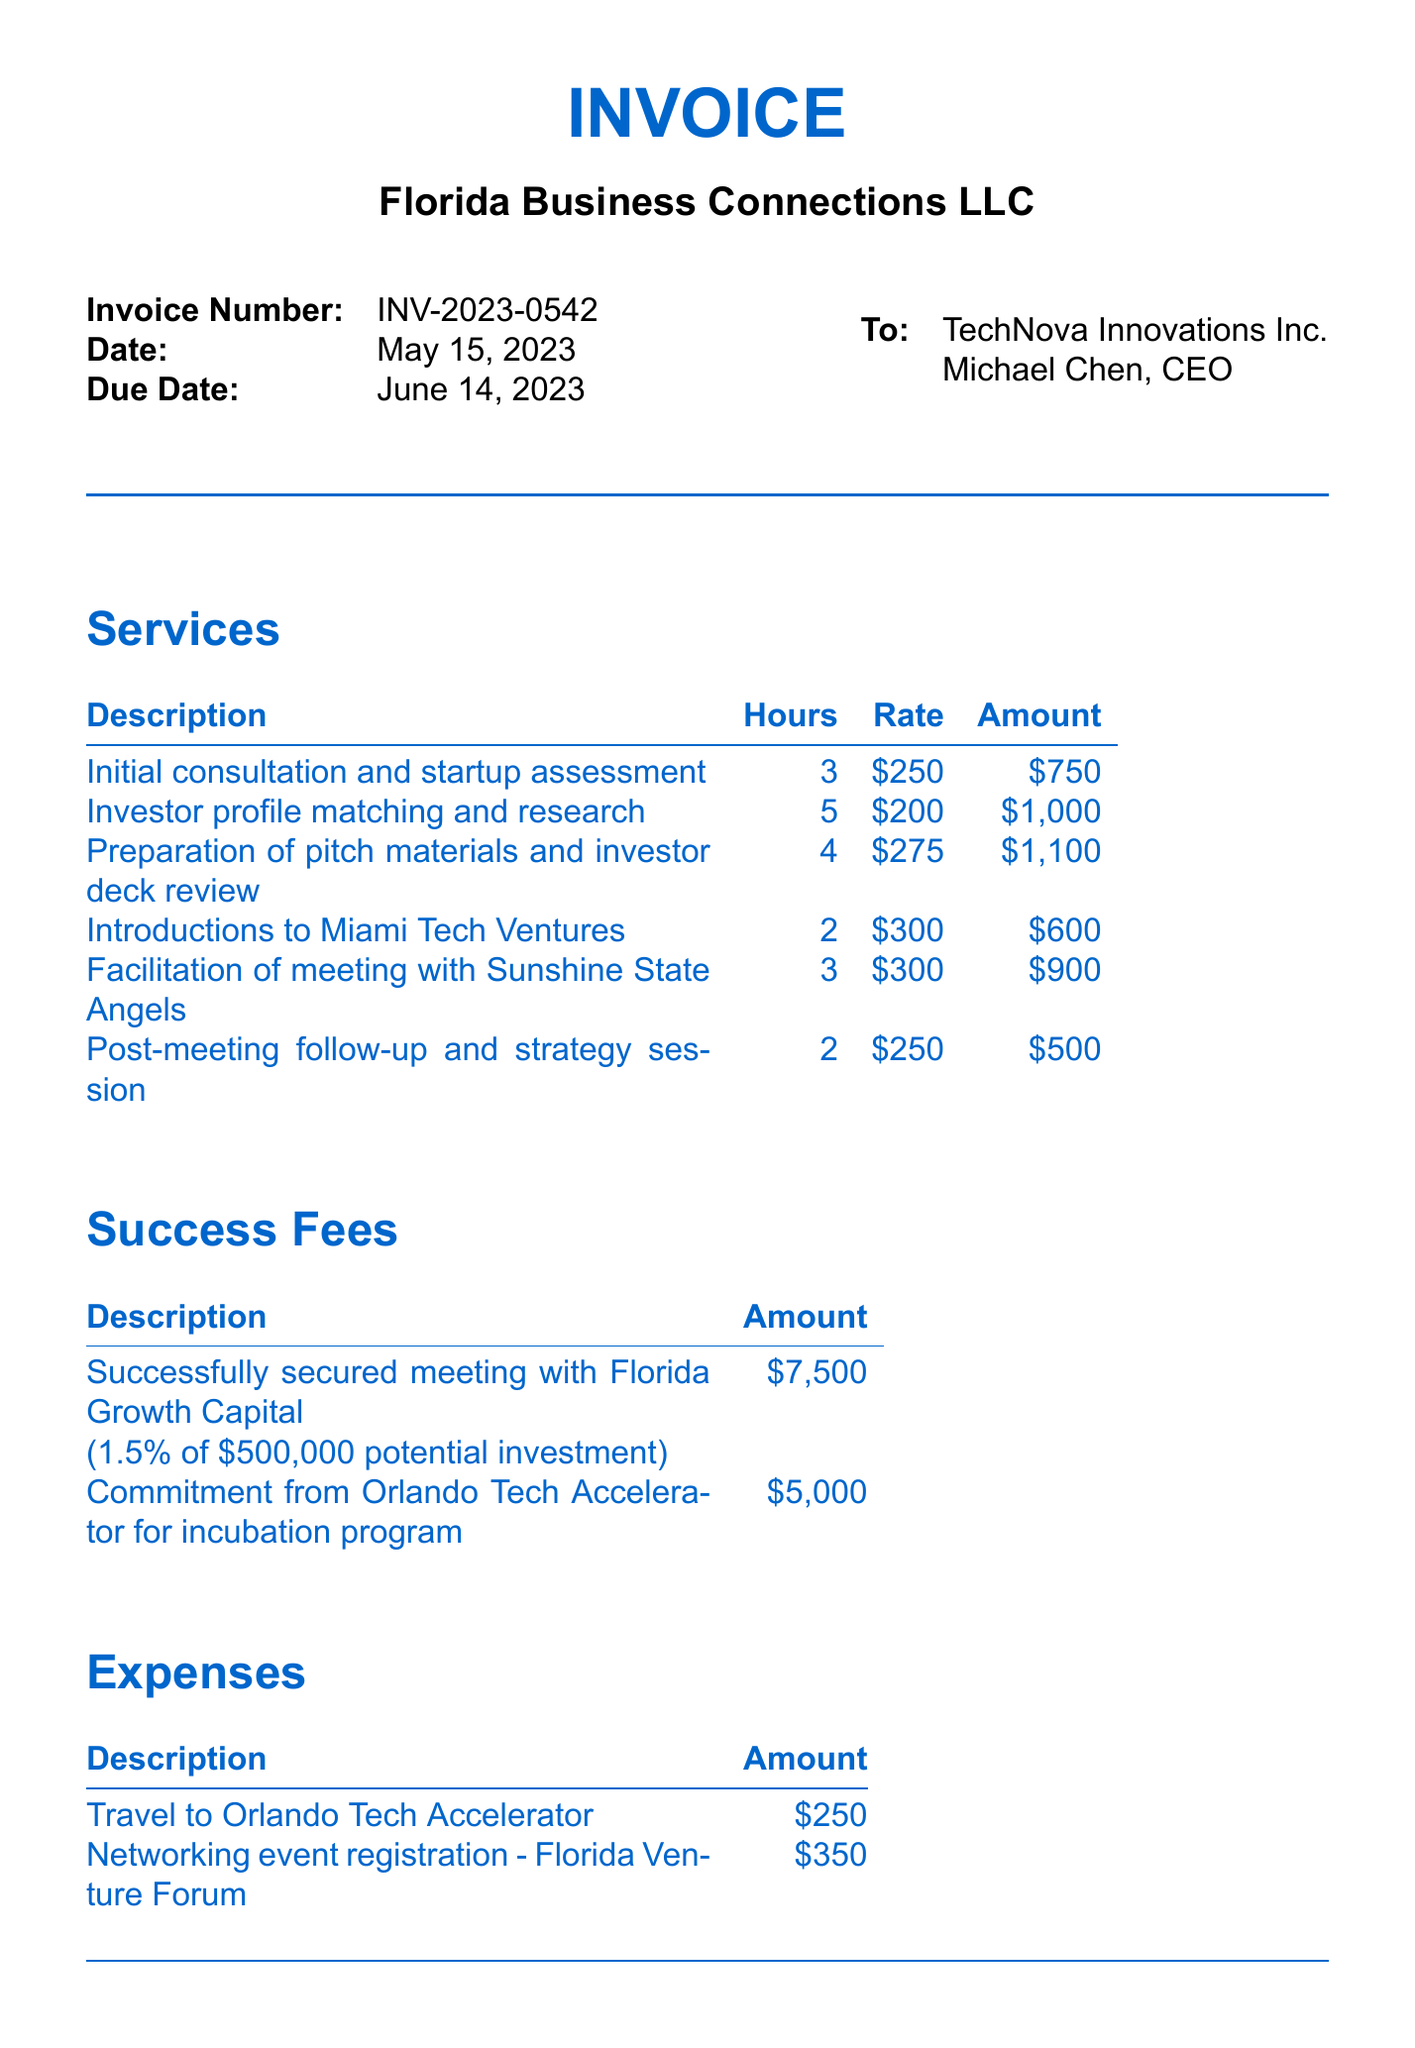What is the invoice number? The invoice number is listed clearly at the top of the document.
Answer: INV-2023-0542 Who is the consultant's name? The consultant's name is mentioned in the invoice details section.
Answer: Sarah Thompson What is the total due amount? The total due amount is calculated in the total section of the invoice.
Answer: $19,116.75 How many hours were spent on preparing pitch materials? The hours for each service are detailed in the services section of the document.
Answer: 4 What is the success fee percentage for the meeting with Florida Growth Capital? The success fee percentage is specified next to the description in the success fees section.
Answer: 1.5% What is the tax rate applied to the subtotal? The tax rate is mentioned in the total section of the invoice.
Answer: 6.5% What is the date the invoice was created? The date of the invoice is stated in the invoice details section.
Answer: May 15, 2023 What payment terms are specified on the invoice? Payment terms are outlined towards the end of the document.
Answer: Net 30 What expenses were incurred for traveling? The expenses section lists details of incurred expenses.
Answer: $250 